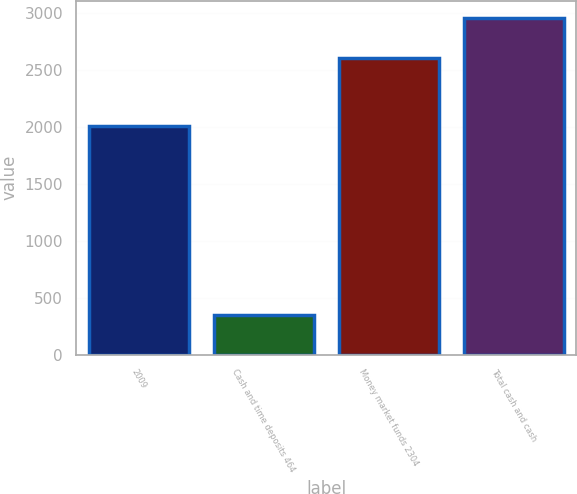Convert chart to OTSL. <chart><loc_0><loc_0><loc_500><loc_500><bar_chart><fcel>2009<fcel>Cash and time deposits 464<fcel>Money market funds 2304<fcel>Total cash and cash<nl><fcel>2008<fcel>349<fcel>2609<fcel>2958<nl></chart> 